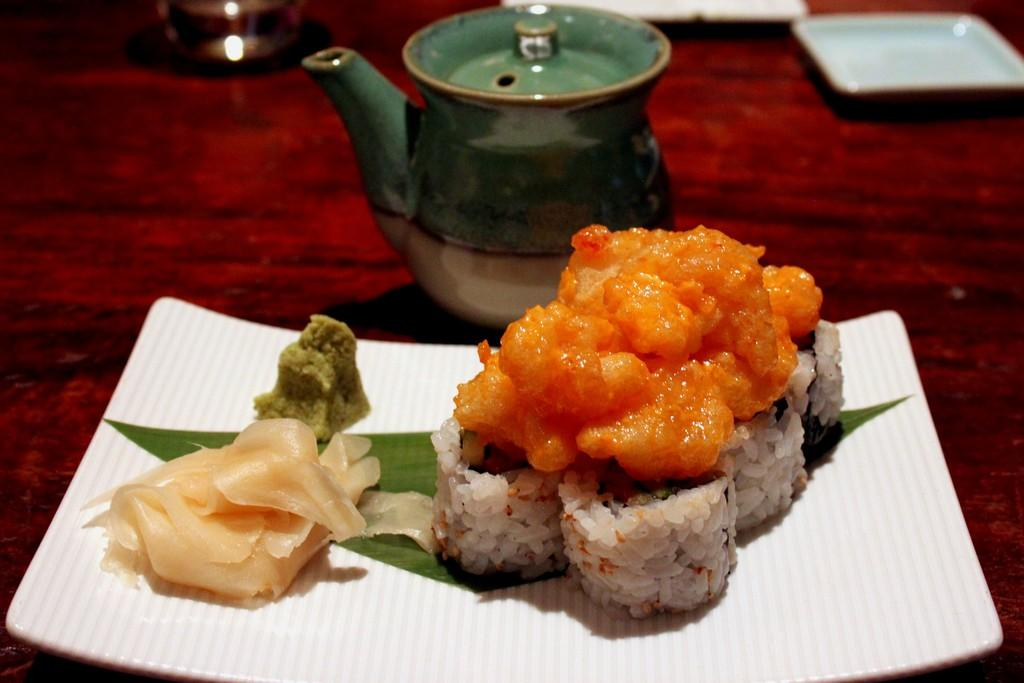What type of dishware can be seen in the image? There are plates in the image. What is the container for serving hot beverages in the image? There is a teapot in the image. What is being served on the plates or in the teapot? There is food in the image. Where are the plates, teapot, and food located? They are on a platform in the image. What type of song is playing in the background of the image? There is no indication of any music or song in the image. 